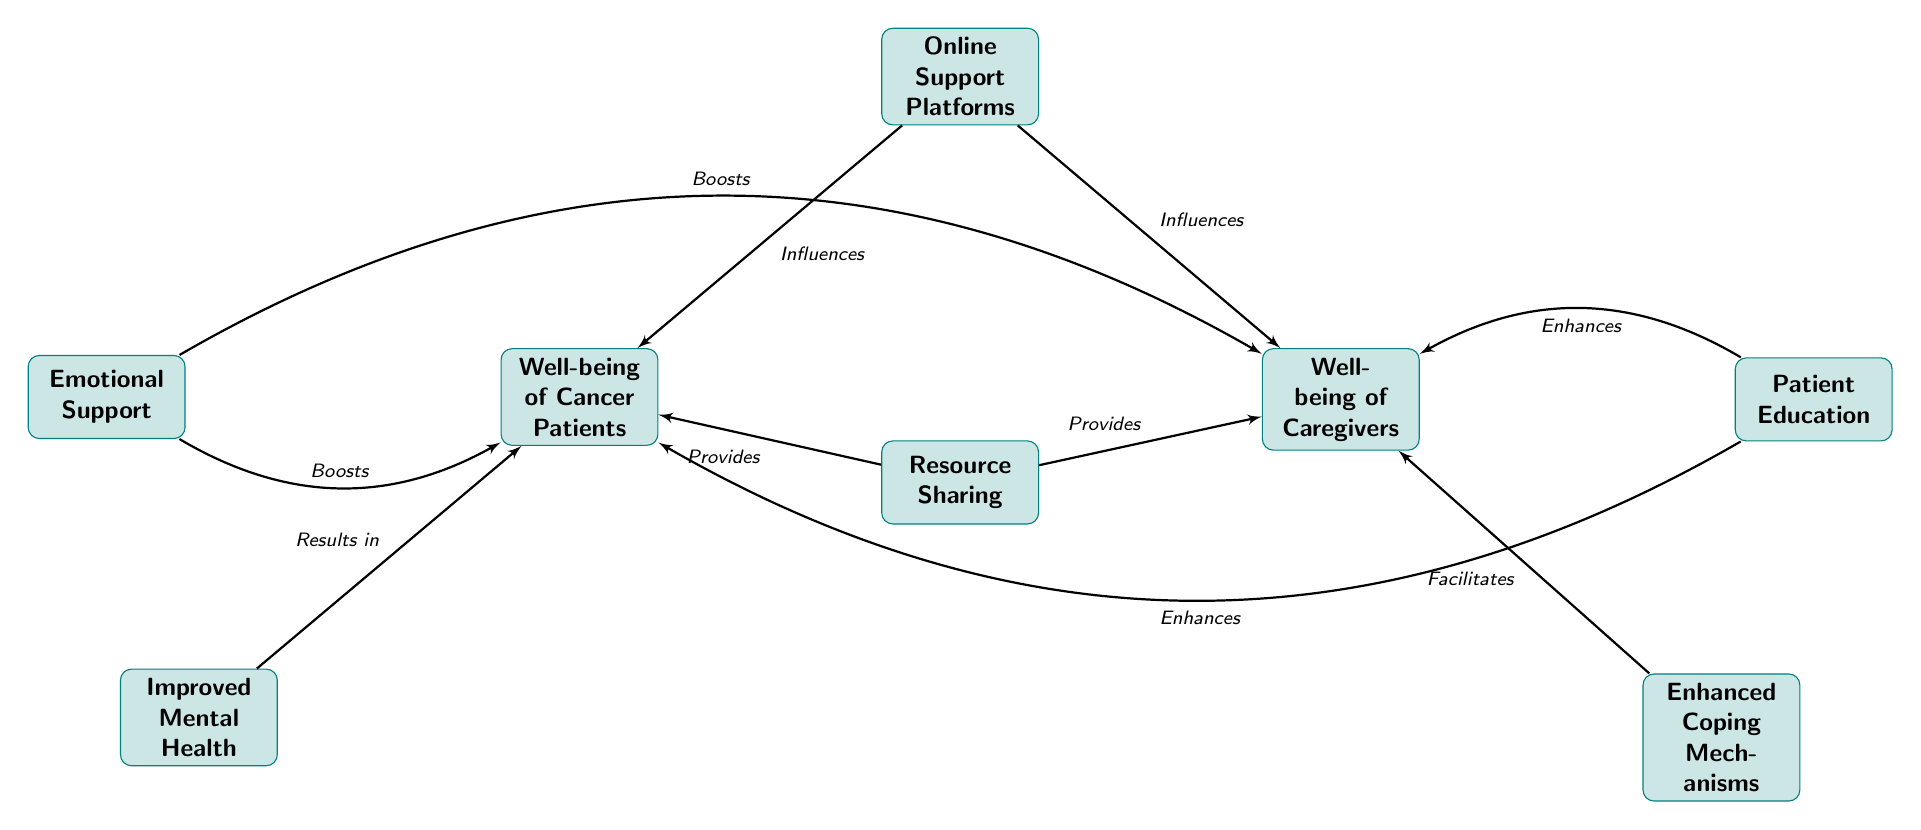What are the two main outcomes of online support platforms? The diagram shows that the two main outcomes influenced by online support platforms are the well-being of cancer patients and the well-being of caregivers.
Answer: Well-being of Cancer Patients, Well-being of Caregivers How many nodes are there in the diagram? By counting the nodes displayed, there are a total of eight nodes representing different concepts.
Answer: 8 Which node boosts the emotional support provided to cancer patients? The emotional support node influences positively and directly leads to the well-being of cancer patients, indicating that emotional support boosts their well-being.
Answer: Well-being of Cancer Patients What does patient education enhance? The diagram indicates that patient education enhances both the well-being of cancer patients and caregivers, as it has outgoing edges directed towards both nodes.
Answer: Well-being of Cancer Patients, Well-being of Caregivers What does resource sharing provide to caregivers? The diagram shows that resource sharing provides enhancements that influence the well-being of caregivers, indicating its crucial role in their support.
Answer: Well-being of Caregivers Which factor results in improved mental health for cancer patients? The influence of improved mental health is a result of emotional support, showing that it directly leads to positive changes in the well-being of cancer patients.
Answer: Improved Mental Health How many edges connect emotional support to the well-being of caregivers? The diagram indicates that there is one edge connecting emotional support to the well-being of caregivers, showing a direct relationship.
Answer: 1 Which node facilitates enhanced coping mechanisms for caregivers? From the diagram, it is clear that enhanced coping mechanisms are facilitated directly by emotional support, indicating its supportive nature for caregivers.
Answer: Enhanced Coping Mechanisms What two nodes do online support platforms influence? The online support platforms are shown to influence two nodes specifically: well-being of cancer patients and well-being of caregivers, showcasing their impact.
Answer: Well-being of Cancer Patients, Well-being of Caregivers 